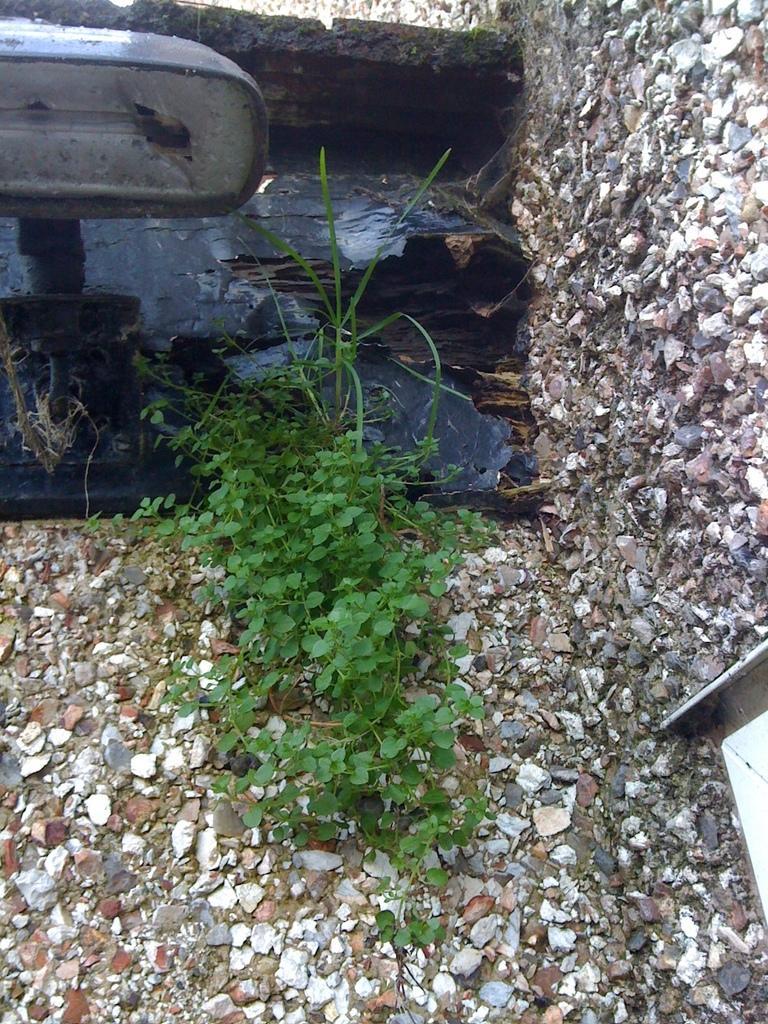Please provide a concise description of this image. In this picture we can see a plant, stones and an object. 